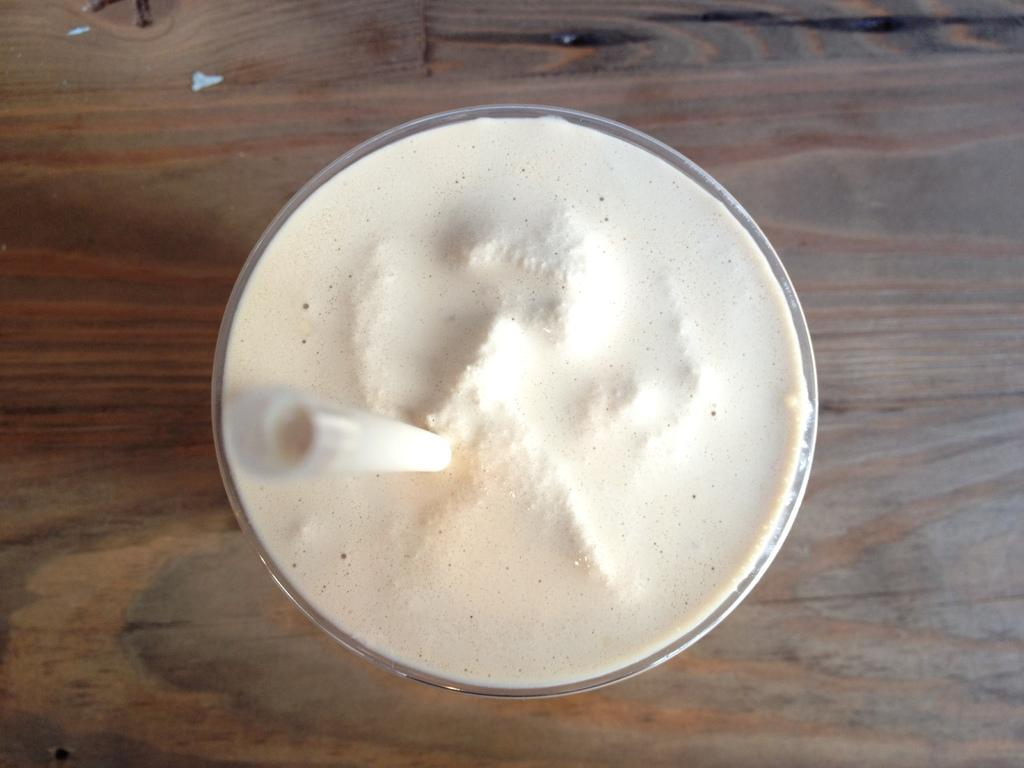What can be seen in the image that is typically used for drinking? There is a glass in the image. What is inside the glass? There is a white color thing in the glass. Is there anything else in the glass besides the white color thing? Yes, there is a straw in the glass. Can you see any bees buzzing around the glass in the image? There are no bees present in the image. Is there a beggar sitting next to the glass in the image? There is no beggar present in the image. 